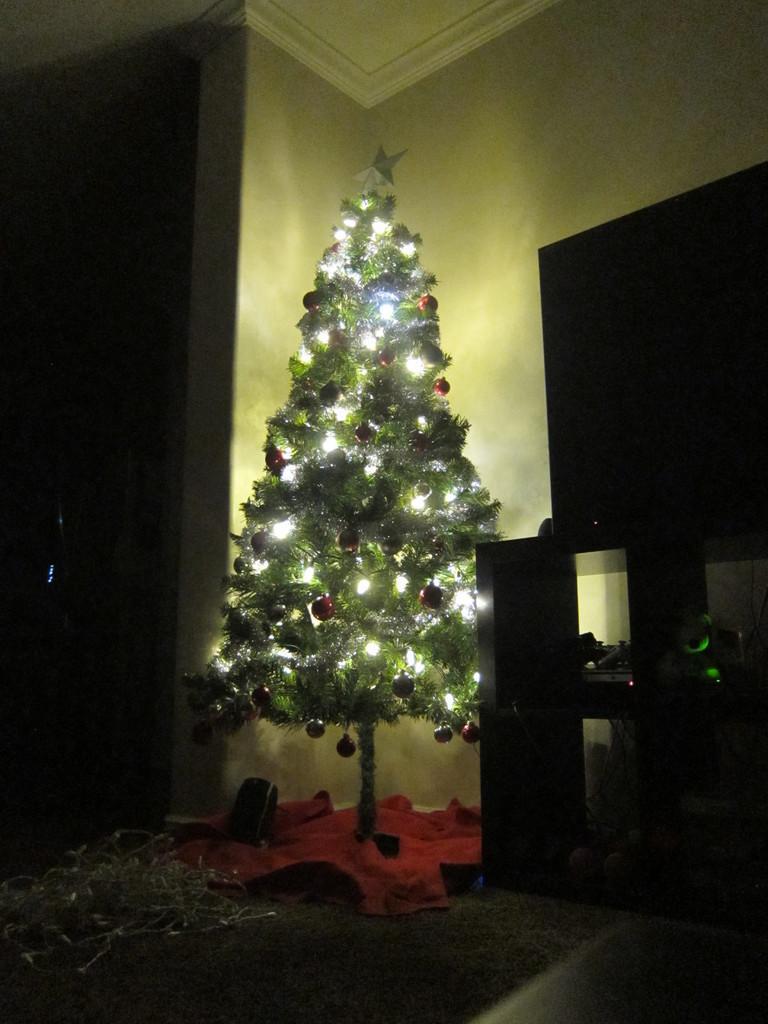In one or two sentences, can you explain what this image depicts? In this image inside the room there is a Christmas tree. This is a table this is a screen. The background is dark. 